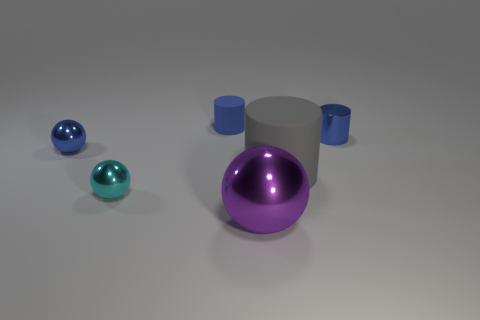There is a large gray rubber object; are there any objects right of it?
Provide a succinct answer. Yes. What number of large yellow objects have the same shape as the big purple metallic object?
Offer a terse response. 0. Are the purple object and the small cylinder on the right side of the purple metal ball made of the same material?
Offer a very short reply. Yes. What number of metallic balls are there?
Provide a succinct answer. 3. There is a matte thing left of the purple ball; how big is it?
Provide a short and direct response. Small. How many blue metallic spheres have the same size as the purple shiny object?
Give a very brief answer. 0. What is the blue thing that is on the right side of the small blue ball and to the left of the gray matte cylinder made of?
Give a very brief answer. Rubber. What material is the thing that is the same size as the purple shiny sphere?
Give a very brief answer. Rubber. How big is the blue cylinder to the right of the rubber cylinder behind the small blue thing to the right of the big purple metal thing?
Ensure brevity in your answer.  Small. What is the size of the other object that is the same material as the gray thing?
Offer a terse response. Small. 